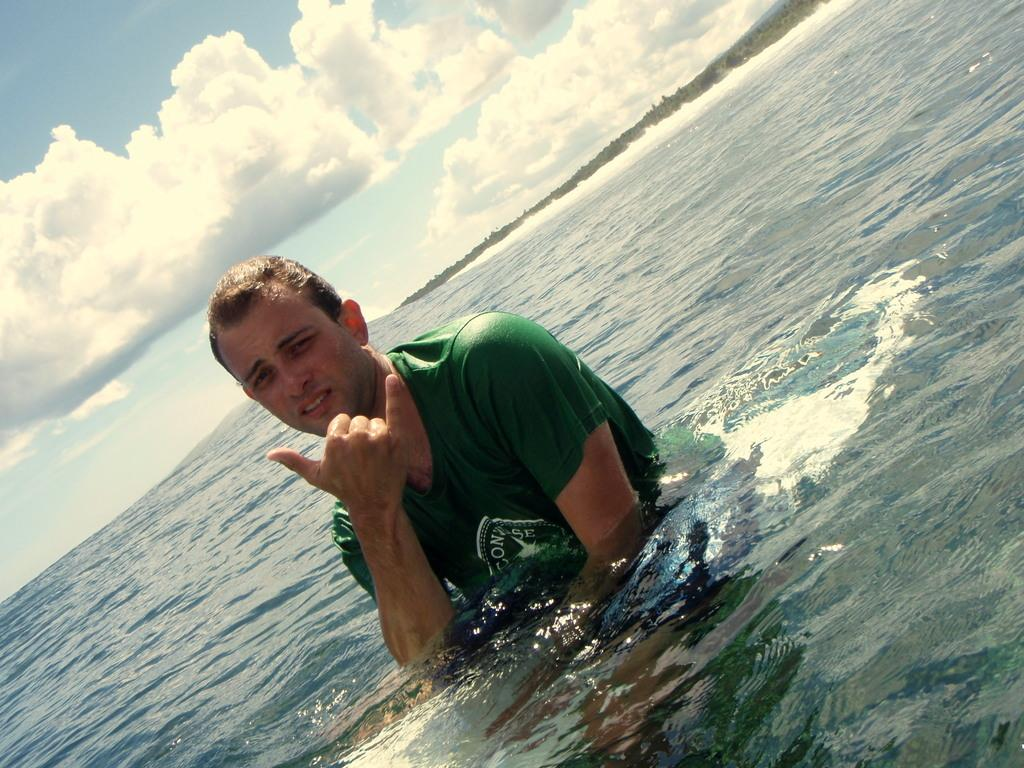What is the man in the image doing? The man is standing in the ocean. What is the man wearing in the image? The man is wearing a green t-shirt. What can be seen in the background of the image? There are trees in the backdrop of the image. How would you describe the sky in the image? The sky is clear in the image. What type of circle is visible on the man's shoes in the image? There is no mention of shoes in the image, so it is impossible to determine if there is a circle on them. 